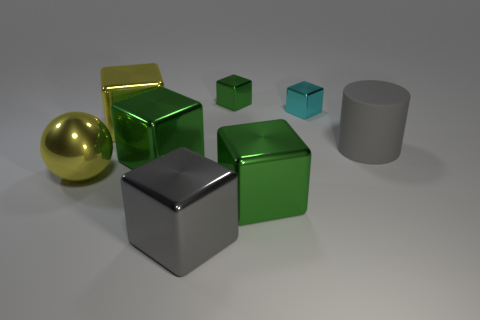There is a yellow thing that is on the left side of the yellow metal cube; is it the same size as the big matte object?
Your answer should be very brief. Yes. Does the matte thing have the same color as the large metal sphere?
Give a very brief answer. No. What number of metal things are both in front of the big cylinder and behind the large yellow block?
Provide a succinct answer. 0. How many large yellow spheres are right of the small metallic cube that is on the right side of the tiny block that is left of the cyan block?
Your answer should be compact. 0. There is a object that is the same color as the shiny sphere; what is its size?
Make the answer very short. Large. There is a gray rubber object; what shape is it?
Offer a very short reply. Cylinder. What number of other tiny cyan blocks have the same material as the cyan block?
Provide a short and direct response. 0. What is the color of the other tiny block that is the same material as the tiny green block?
Your response must be concise. Cyan. Do the yellow block and the green shiny object that is behind the gray rubber object have the same size?
Provide a succinct answer. No. What material is the large thing that is in front of the big shiny thing to the right of the gray object that is in front of the yellow metallic ball?
Give a very brief answer. Metal. 